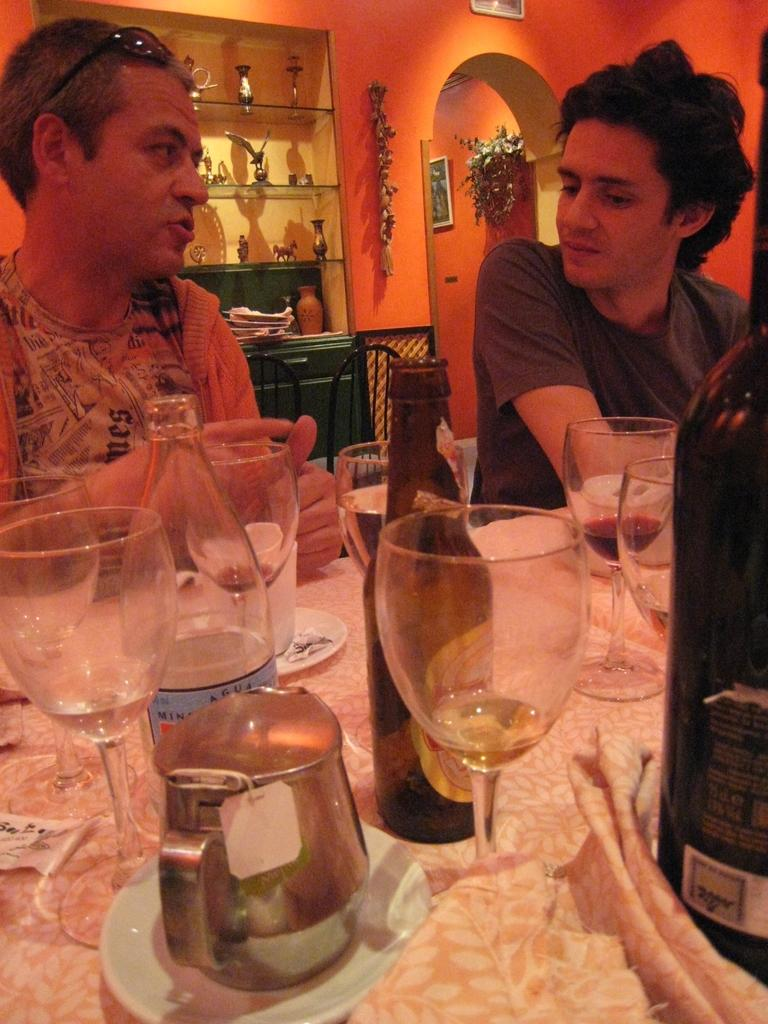What piece of furniture is present in the image? There is a table in the image. What objects are placed on the table? There are glasses and bottles on the table. How many people are sitting at the table? There are two people sitting at the table. What color is the wall visible in the image? There is an orange-colored wall in the image. Can you see any clouds in the image? There are no clouds visible in the image; it appears to be an indoor setting with an orange-colored wall. 